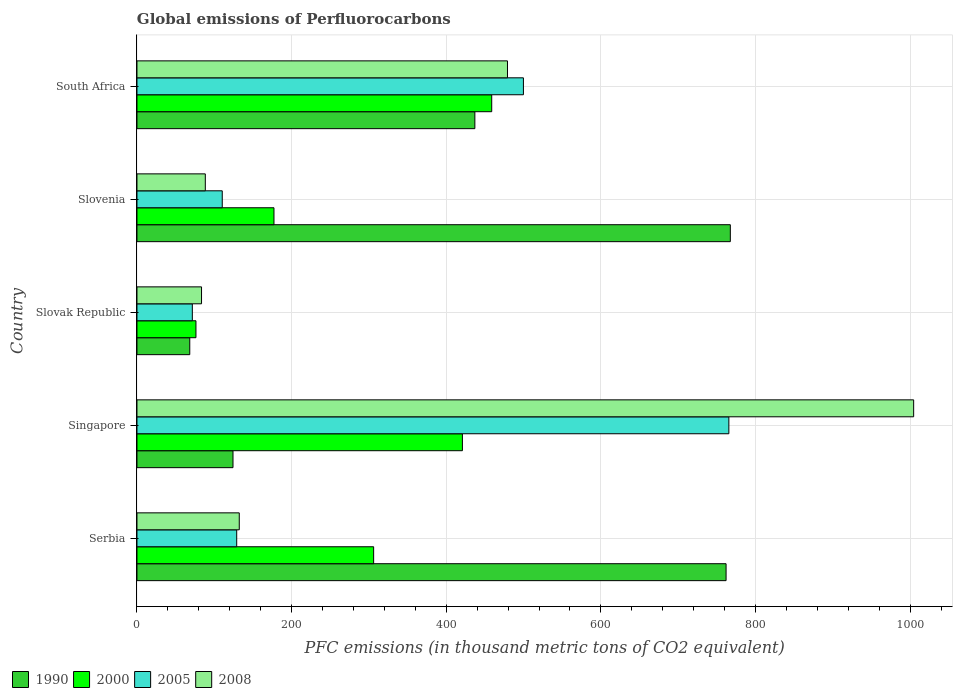How many groups of bars are there?
Your answer should be compact. 5. Are the number of bars on each tick of the Y-axis equal?
Keep it short and to the point. Yes. How many bars are there on the 5th tick from the bottom?
Your response must be concise. 4. What is the label of the 2nd group of bars from the top?
Ensure brevity in your answer.  Slovenia. In how many cases, is the number of bars for a given country not equal to the number of legend labels?
Your answer should be very brief. 0. What is the global emissions of Perfluorocarbons in 1990 in Slovenia?
Give a very brief answer. 767.4. Across all countries, what is the maximum global emissions of Perfluorocarbons in 2008?
Give a very brief answer. 1004.5. Across all countries, what is the minimum global emissions of Perfluorocarbons in 2005?
Your answer should be compact. 71.6. In which country was the global emissions of Perfluorocarbons in 2005 maximum?
Keep it short and to the point. Singapore. In which country was the global emissions of Perfluorocarbons in 1990 minimum?
Your answer should be compact. Slovak Republic. What is the total global emissions of Perfluorocarbons in 2005 in the graph?
Keep it short and to the point. 1576.2. What is the difference between the global emissions of Perfluorocarbons in 2008 in Slovak Republic and that in Slovenia?
Offer a terse response. -4.9. What is the difference between the global emissions of Perfluorocarbons in 2000 in Serbia and the global emissions of Perfluorocarbons in 2005 in South Africa?
Your answer should be very brief. -193.7. What is the average global emissions of Perfluorocarbons in 1990 per country?
Provide a short and direct response. 431.76. What is the difference between the global emissions of Perfluorocarbons in 2008 and global emissions of Perfluorocarbons in 1990 in Slovak Republic?
Offer a terse response. 15.2. In how many countries, is the global emissions of Perfluorocarbons in 1990 greater than 200 thousand metric tons?
Offer a terse response. 3. What is the ratio of the global emissions of Perfluorocarbons in 2000 in Singapore to that in South Africa?
Your response must be concise. 0.92. Is the global emissions of Perfluorocarbons in 2008 in Serbia less than that in Slovenia?
Make the answer very short. No. Is the difference between the global emissions of Perfluorocarbons in 2008 in Serbia and South Africa greater than the difference between the global emissions of Perfluorocarbons in 1990 in Serbia and South Africa?
Provide a succinct answer. No. What is the difference between the highest and the second highest global emissions of Perfluorocarbons in 2000?
Offer a very short reply. 37.9. What is the difference between the highest and the lowest global emissions of Perfluorocarbons in 2000?
Your answer should be very brief. 382.5. Is the sum of the global emissions of Perfluorocarbons in 2008 in Slovak Republic and South Africa greater than the maximum global emissions of Perfluorocarbons in 1990 across all countries?
Provide a succinct answer. No. Is it the case that in every country, the sum of the global emissions of Perfluorocarbons in 1990 and global emissions of Perfluorocarbons in 2000 is greater than the sum of global emissions of Perfluorocarbons in 2005 and global emissions of Perfluorocarbons in 2008?
Offer a terse response. No. What does the 3rd bar from the top in Serbia represents?
Make the answer very short. 2000. Does the graph contain any zero values?
Offer a very short reply. No. Does the graph contain grids?
Make the answer very short. Yes. How many legend labels are there?
Provide a short and direct response. 4. How are the legend labels stacked?
Provide a succinct answer. Horizontal. What is the title of the graph?
Give a very brief answer. Global emissions of Perfluorocarbons. What is the label or title of the X-axis?
Keep it short and to the point. PFC emissions (in thousand metric tons of CO2 equivalent). What is the PFC emissions (in thousand metric tons of CO2 equivalent) in 1990 in Serbia?
Your response must be concise. 761.9. What is the PFC emissions (in thousand metric tons of CO2 equivalent) of 2000 in Serbia?
Ensure brevity in your answer.  306.1. What is the PFC emissions (in thousand metric tons of CO2 equivalent) in 2005 in Serbia?
Your answer should be very brief. 129. What is the PFC emissions (in thousand metric tons of CO2 equivalent) of 2008 in Serbia?
Offer a very short reply. 132.3. What is the PFC emissions (in thousand metric tons of CO2 equivalent) in 1990 in Singapore?
Make the answer very short. 124.2. What is the PFC emissions (in thousand metric tons of CO2 equivalent) in 2000 in Singapore?
Your answer should be compact. 420.9. What is the PFC emissions (in thousand metric tons of CO2 equivalent) in 2005 in Singapore?
Your response must be concise. 765.5. What is the PFC emissions (in thousand metric tons of CO2 equivalent) of 2008 in Singapore?
Your answer should be very brief. 1004.5. What is the PFC emissions (in thousand metric tons of CO2 equivalent) of 1990 in Slovak Republic?
Provide a succinct answer. 68.3. What is the PFC emissions (in thousand metric tons of CO2 equivalent) in 2000 in Slovak Republic?
Make the answer very short. 76.3. What is the PFC emissions (in thousand metric tons of CO2 equivalent) of 2005 in Slovak Republic?
Make the answer very short. 71.6. What is the PFC emissions (in thousand metric tons of CO2 equivalent) of 2008 in Slovak Republic?
Offer a terse response. 83.5. What is the PFC emissions (in thousand metric tons of CO2 equivalent) of 1990 in Slovenia?
Keep it short and to the point. 767.4. What is the PFC emissions (in thousand metric tons of CO2 equivalent) of 2000 in Slovenia?
Your response must be concise. 177.2. What is the PFC emissions (in thousand metric tons of CO2 equivalent) in 2005 in Slovenia?
Keep it short and to the point. 110.3. What is the PFC emissions (in thousand metric tons of CO2 equivalent) in 2008 in Slovenia?
Your answer should be compact. 88.4. What is the PFC emissions (in thousand metric tons of CO2 equivalent) in 1990 in South Africa?
Keep it short and to the point. 437. What is the PFC emissions (in thousand metric tons of CO2 equivalent) of 2000 in South Africa?
Provide a short and direct response. 458.8. What is the PFC emissions (in thousand metric tons of CO2 equivalent) of 2005 in South Africa?
Offer a terse response. 499.8. What is the PFC emissions (in thousand metric tons of CO2 equivalent) of 2008 in South Africa?
Your response must be concise. 479.2. Across all countries, what is the maximum PFC emissions (in thousand metric tons of CO2 equivalent) of 1990?
Offer a terse response. 767.4. Across all countries, what is the maximum PFC emissions (in thousand metric tons of CO2 equivalent) of 2000?
Your answer should be compact. 458.8. Across all countries, what is the maximum PFC emissions (in thousand metric tons of CO2 equivalent) of 2005?
Your response must be concise. 765.5. Across all countries, what is the maximum PFC emissions (in thousand metric tons of CO2 equivalent) in 2008?
Ensure brevity in your answer.  1004.5. Across all countries, what is the minimum PFC emissions (in thousand metric tons of CO2 equivalent) of 1990?
Provide a succinct answer. 68.3. Across all countries, what is the minimum PFC emissions (in thousand metric tons of CO2 equivalent) in 2000?
Ensure brevity in your answer.  76.3. Across all countries, what is the minimum PFC emissions (in thousand metric tons of CO2 equivalent) of 2005?
Your response must be concise. 71.6. Across all countries, what is the minimum PFC emissions (in thousand metric tons of CO2 equivalent) in 2008?
Offer a terse response. 83.5. What is the total PFC emissions (in thousand metric tons of CO2 equivalent) of 1990 in the graph?
Make the answer very short. 2158.8. What is the total PFC emissions (in thousand metric tons of CO2 equivalent) of 2000 in the graph?
Your response must be concise. 1439.3. What is the total PFC emissions (in thousand metric tons of CO2 equivalent) of 2005 in the graph?
Your answer should be compact. 1576.2. What is the total PFC emissions (in thousand metric tons of CO2 equivalent) in 2008 in the graph?
Ensure brevity in your answer.  1787.9. What is the difference between the PFC emissions (in thousand metric tons of CO2 equivalent) in 1990 in Serbia and that in Singapore?
Ensure brevity in your answer.  637.7. What is the difference between the PFC emissions (in thousand metric tons of CO2 equivalent) of 2000 in Serbia and that in Singapore?
Keep it short and to the point. -114.8. What is the difference between the PFC emissions (in thousand metric tons of CO2 equivalent) in 2005 in Serbia and that in Singapore?
Give a very brief answer. -636.5. What is the difference between the PFC emissions (in thousand metric tons of CO2 equivalent) of 2008 in Serbia and that in Singapore?
Offer a terse response. -872.2. What is the difference between the PFC emissions (in thousand metric tons of CO2 equivalent) in 1990 in Serbia and that in Slovak Republic?
Offer a very short reply. 693.6. What is the difference between the PFC emissions (in thousand metric tons of CO2 equivalent) of 2000 in Serbia and that in Slovak Republic?
Your response must be concise. 229.8. What is the difference between the PFC emissions (in thousand metric tons of CO2 equivalent) of 2005 in Serbia and that in Slovak Republic?
Keep it short and to the point. 57.4. What is the difference between the PFC emissions (in thousand metric tons of CO2 equivalent) in 2008 in Serbia and that in Slovak Republic?
Your response must be concise. 48.8. What is the difference between the PFC emissions (in thousand metric tons of CO2 equivalent) in 2000 in Serbia and that in Slovenia?
Your response must be concise. 128.9. What is the difference between the PFC emissions (in thousand metric tons of CO2 equivalent) of 2005 in Serbia and that in Slovenia?
Ensure brevity in your answer.  18.7. What is the difference between the PFC emissions (in thousand metric tons of CO2 equivalent) of 2008 in Serbia and that in Slovenia?
Give a very brief answer. 43.9. What is the difference between the PFC emissions (in thousand metric tons of CO2 equivalent) in 1990 in Serbia and that in South Africa?
Your answer should be very brief. 324.9. What is the difference between the PFC emissions (in thousand metric tons of CO2 equivalent) of 2000 in Serbia and that in South Africa?
Give a very brief answer. -152.7. What is the difference between the PFC emissions (in thousand metric tons of CO2 equivalent) of 2005 in Serbia and that in South Africa?
Keep it short and to the point. -370.8. What is the difference between the PFC emissions (in thousand metric tons of CO2 equivalent) of 2008 in Serbia and that in South Africa?
Your answer should be very brief. -346.9. What is the difference between the PFC emissions (in thousand metric tons of CO2 equivalent) in 1990 in Singapore and that in Slovak Republic?
Keep it short and to the point. 55.9. What is the difference between the PFC emissions (in thousand metric tons of CO2 equivalent) in 2000 in Singapore and that in Slovak Republic?
Offer a terse response. 344.6. What is the difference between the PFC emissions (in thousand metric tons of CO2 equivalent) of 2005 in Singapore and that in Slovak Republic?
Provide a succinct answer. 693.9. What is the difference between the PFC emissions (in thousand metric tons of CO2 equivalent) of 2008 in Singapore and that in Slovak Republic?
Provide a succinct answer. 921. What is the difference between the PFC emissions (in thousand metric tons of CO2 equivalent) of 1990 in Singapore and that in Slovenia?
Offer a very short reply. -643.2. What is the difference between the PFC emissions (in thousand metric tons of CO2 equivalent) of 2000 in Singapore and that in Slovenia?
Your response must be concise. 243.7. What is the difference between the PFC emissions (in thousand metric tons of CO2 equivalent) in 2005 in Singapore and that in Slovenia?
Provide a short and direct response. 655.2. What is the difference between the PFC emissions (in thousand metric tons of CO2 equivalent) of 2008 in Singapore and that in Slovenia?
Offer a very short reply. 916.1. What is the difference between the PFC emissions (in thousand metric tons of CO2 equivalent) in 1990 in Singapore and that in South Africa?
Keep it short and to the point. -312.8. What is the difference between the PFC emissions (in thousand metric tons of CO2 equivalent) of 2000 in Singapore and that in South Africa?
Keep it short and to the point. -37.9. What is the difference between the PFC emissions (in thousand metric tons of CO2 equivalent) in 2005 in Singapore and that in South Africa?
Provide a succinct answer. 265.7. What is the difference between the PFC emissions (in thousand metric tons of CO2 equivalent) in 2008 in Singapore and that in South Africa?
Your response must be concise. 525.3. What is the difference between the PFC emissions (in thousand metric tons of CO2 equivalent) in 1990 in Slovak Republic and that in Slovenia?
Offer a terse response. -699.1. What is the difference between the PFC emissions (in thousand metric tons of CO2 equivalent) in 2000 in Slovak Republic and that in Slovenia?
Provide a short and direct response. -100.9. What is the difference between the PFC emissions (in thousand metric tons of CO2 equivalent) in 2005 in Slovak Republic and that in Slovenia?
Offer a very short reply. -38.7. What is the difference between the PFC emissions (in thousand metric tons of CO2 equivalent) in 1990 in Slovak Republic and that in South Africa?
Ensure brevity in your answer.  -368.7. What is the difference between the PFC emissions (in thousand metric tons of CO2 equivalent) in 2000 in Slovak Republic and that in South Africa?
Ensure brevity in your answer.  -382.5. What is the difference between the PFC emissions (in thousand metric tons of CO2 equivalent) in 2005 in Slovak Republic and that in South Africa?
Ensure brevity in your answer.  -428.2. What is the difference between the PFC emissions (in thousand metric tons of CO2 equivalent) in 2008 in Slovak Republic and that in South Africa?
Keep it short and to the point. -395.7. What is the difference between the PFC emissions (in thousand metric tons of CO2 equivalent) of 1990 in Slovenia and that in South Africa?
Your response must be concise. 330.4. What is the difference between the PFC emissions (in thousand metric tons of CO2 equivalent) in 2000 in Slovenia and that in South Africa?
Ensure brevity in your answer.  -281.6. What is the difference between the PFC emissions (in thousand metric tons of CO2 equivalent) in 2005 in Slovenia and that in South Africa?
Give a very brief answer. -389.5. What is the difference between the PFC emissions (in thousand metric tons of CO2 equivalent) of 2008 in Slovenia and that in South Africa?
Your response must be concise. -390.8. What is the difference between the PFC emissions (in thousand metric tons of CO2 equivalent) in 1990 in Serbia and the PFC emissions (in thousand metric tons of CO2 equivalent) in 2000 in Singapore?
Offer a very short reply. 341. What is the difference between the PFC emissions (in thousand metric tons of CO2 equivalent) of 1990 in Serbia and the PFC emissions (in thousand metric tons of CO2 equivalent) of 2008 in Singapore?
Ensure brevity in your answer.  -242.6. What is the difference between the PFC emissions (in thousand metric tons of CO2 equivalent) of 2000 in Serbia and the PFC emissions (in thousand metric tons of CO2 equivalent) of 2005 in Singapore?
Your answer should be compact. -459.4. What is the difference between the PFC emissions (in thousand metric tons of CO2 equivalent) of 2000 in Serbia and the PFC emissions (in thousand metric tons of CO2 equivalent) of 2008 in Singapore?
Your response must be concise. -698.4. What is the difference between the PFC emissions (in thousand metric tons of CO2 equivalent) of 2005 in Serbia and the PFC emissions (in thousand metric tons of CO2 equivalent) of 2008 in Singapore?
Give a very brief answer. -875.5. What is the difference between the PFC emissions (in thousand metric tons of CO2 equivalent) of 1990 in Serbia and the PFC emissions (in thousand metric tons of CO2 equivalent) of 2000 in Slovak Republic?
Your response must be concise. 685.6. What is the difference between the PFC emissions (in thousand metric tons of CO2 equivalent) in 1990 in Serbia and the PFC emissions (in thousand metric tons of CO2 equivalent) in 2005 in Slovak Republic?
Provide a succinct answer. 690.3. What is the difference between the PFC emissions (in thousand metric tons of CO2 equivalent) of 1990 in Serbia and the PFC emissions (in thousand metric tons of CO2 equivalent) of 2008 in Slovak Republic?
Ensure brevity in your answer.  678.4. What is the difference between the PFC emissions (in thousand metric tons of CO2 equivalent) of 2000 in Serbia and the PFC emissions (in thousand metric tons of CO2 equivalent) of 2005 in Slovak Republic?
Provide a short and direct response. 234.5. What is the difference between the PFC emissions (in thousand metric tons of CO2 equivalent) in 2000 in Serbia and the PFC emissions (in thousand metric tons of CO2 equivalent) in 2008 in Slovak Republic?
Ensure brevity in your answer.  222.6. What is the difference between the PFC emissions (in thousand metric tons of CO2 equivalent) in 2005 in Serbia and the PFC emissions (in thousand metric tons of CO2 equivalent) in 2008 in Slovak Republic?
Give a very brief answer. 45.5. What is the difference between the PFC emissions (in thousand metric tons of CO2 equivalent) of 1990 in Serbia and the PFC emissions (in thousand metric tons of CO2 equivalent) of 2000 in Slovenia?
Provide a short and direct response. 584.7. What is the difference between the PFC emissions (in thousand metric tons of CO2 equivalent) of 1990 in Serbia and the PFC emissions (in thousand metric tons of CO2 equivalent) of 2005 in Slovenia?
Your response must be concise. 651.6. What is the difference between the PFC emissions (in thousand metric tons of CO2 equivalent) in 1990 in Serbia and the PFC emissions (in thousand metric tons of CO2 equivalent) in 2008 in Slovenia?
Your response must be concise. 673.5. What is the difference between the PFC emissions (in thousand metric tons of CO2 equivalent) of 2000 in Serbia and the PFC emissions (in thousand metric tons of CO2 equivalent) of 2005 in Slovenia?
Offer a terse response. 195.8. What is the difference between the PFC emissions (in thousand metric tons of CO2 equivalent) in 2000 in Serbia and the PFC emissions (in thousand metric tons of CO2 equivalent) in 2008 in Slovenia?
Your answer should be compact. 217.7. What is the difference between the PFC emissions (in thousand metric tons of CO2 equivalent) in 2005 in Serbia and the PFC emissions (in thousand metric tons of CO2 equivalent) in 2008 in Slovenia?
Provide a succinct answer. 40.6. What is the difference between the PFC emissions (in thousand metric tons of CO2 equivalent) of 1990 in Serbia and the PFC emissions (in thousand metric tons of CO2 equivalent) of 2000 in South Africa?
Give a very brief answer. 303.1. What is the difference between the PFC emissions (in thousand metric tons of CO2 equivalent) in 1990 in Serbia and the PFC emissions (in thousand metric tons of CO2 equivalent) in 2005 in South Africa?
Your answer should be very brief. 262.1. What is the difference between the PFC emissions (in thousand metric tons of CO2 equivalent) of 1990 in Serbia and the PFC emissions (in thousand metric tons of CO2 equivalent) of 2008 in South Africa?
Your answer should be very brief. 282.7. What is the difference between the PFC emissions (in thousand metric tons of CO2 equivalent) of 2000 in Serbia and the PFC emissions (in thousand metric tons of CO2 equivalent) of 2005 in South Africa?
Provide a short and direct response. -193.7. What is the difference between the PFC emissions (in thousand metric tons of CO2 equivalent) of 2000 in Serbia and the PFC emissions (in thousand metric tons of CO2 equivalent) of 2008 in South Africa?
Your answer should be compact. -173.1. What is the difference between the PFC emissions (in thousand metric tons of CO2 equivalent) of 2005 in Serbia and the PFC emissions (in thousand metric tons of CO2 equivalent) of 2008 in South Africa?
Provide a succinct answer. -350.2. What is the difference between the PFC emissions (in thousand metric tons of CO2 equivalent) of 1990 in Singapore and the PFC emissions (in thousand metric tons of CO2 equivalent) of 2000 in Slovak Republic?
Give a very brief answer. 47.9. What is the difference between the PFC emissions (in thousand metric tons of CO2 equivalent) of 1990 in Singapore and the PFC emissions (in thousand metric tons of CO2 equivalent) of 2005 in Slovak Republic?
Your answer should be compact. 52.6. What is the difference between the PFC emissions (in thousand metric tons of CO2 equivalent) in 1990 in Singapore and the PFC emissions (in thousand metric tons of CO2 equivalent) in 2008 in Slovak Republic?
Your answer should be very brief. 40.7. What is the difference between the PFC emissions (in thousand metric tons of CO2 equivalent) of 2000 in Singapore and the PFC emissions (in thousand metric tons of CO2 equivalent) of 2005 in Slovak Republic?
Your answer should be compact. 349.3. What is the difference between the PFC emissions (in thousand metric tons of CO2 equivalent) of 2000 in Singapore and the PFC emissions (in thousand metric tons of CO2 equivalent) of 2008 in Slovak Republic?
Provide a succinct answer. 337.4. What is the difference between the PFC emissions (in thousand metric tons of CO2 equivalent) of 2005 in Singapore and the PFC emissions (in thousand metric tons of CO2 equivalent) of 2008 in Slovak Republic?
Provide a short and direct response. 682. What is the difference between the PFC emissions (in thousand metric tons of CO2 equivalent) of 1990 in Singapore and the PFC emissions (in thousand metric tons of CO2 equivalent) of 2000 in Slovenia?
Your response must be concise. -53. What is the difference between the PFC emissions (in thousand metric tons of CO2 equivalent) of 1990 in Singapore and the PFC emissions (in thousand metric tons of CO2 equivalent) of 2005 in Slovenia?
Ensure brevity in your answer.  13.9. What is the difference between the PFC emissions (in thousand metric tons of CO2 equivalent) of 1990 in Singapore and the PFC emissions (in thousand metric tons of CO2 equivalent) of 2008 in Slovenia?
Keep it short and to the point. 35.8. What is the difference between the PFC emissions (in thousand metric tons of CO2 equivalent) of 2000 in Singapore and the PFC emissions (in thousand metric tons of CO2 equivalent) of 2005 in Slovenia?
Ensure brevity in your answer.  310.6. What is the difference between the PFC emissions (in thousand metric tons of CO2 equivalent) in 2000 in Singapore and the PFC emissions (in thousand metric tons of CO2 equivalent) in 2008 in Slovenia?
Your answer should be compact. 332.5. What is the difference between the PFC emissions (in thousand metric tons of CO2 equivalent) of 2005 in Singapore and the PFC emissions (in thousand metric tons of CO2 equivalent) of 2008 in Slovenia?
Make the answer very short. 677.1. What is the difference between the PFC emissions (in thousand metric tons of CO2 equivalent) of 1990 in Singapore and the PFC emissions (in thousand metric tons of CO2 equivalent) of 2000 in South Africa?
Your answer should be compact. -334.6. What is the difference between the PFC emissions (in thousand metric tons of CO2 equivalent) of 1990 in Singapore and the PFC emissions (in thousand metric tons of CO2 equivalent) of 2005 in South Africa?
Provide a succinct answer. -375.6. What is the difference between the PFC emissions (in thousand metric tons of CO2 equivalent) of 1990 in Singapore and the PFC emissions (in thousand metric tons of CO2 equivalent) of 2008 in South Africa?
Keep it short and to the point. -355. What is the difference between the PFC emissions (in thousand metric tons of CO2 equivalent) of 2000 in Singapore and the PFC emissions (in thousand metric tons of CO2 equivalent) of 2005 in South Africa?
Your answer should be compact. -78.9. What is the difference between the PFC emissions (in thousand metric tons of CO2 equivalent) in 2000 in Singapore and the PFC emissions (in thousand metric tons of CO2 equivalent) in 2008 in South Africa?
Provide a short and direct response. -58.3. What is the difference between the PFC emissions (in thousand metric tons of CO2 equivalent) in 2005 in Singapore and the PFC emissions (in thousand metric tons of CO2 equivalent) in 2008 in South Africa?
Provide a succinct answer. 286.3. What is the difference between the PFC emissions (in thousand metric tons of CO2 equivalent) in 1990 in Slovak Republic and the PFC emissions (in thousand metric tons of CO2 equivalent) in 2000 in Slovenia?
Offer a very short reply. -108.9. What is the difference between the PFC emissions (in thousand metric tons of CO2 equivalent) in 1990 in Slovak Republic and the PFC emissions (in thousand metric tons of CO2 equivalent) in 2005 in Slovenia?
Make the answer very short. -42. What is the difference between the PFC emissions (in thousand metric tons of CO2 equivalent) in 1990 in Slovak Republic and the PFC emissions (in thousand metric tons of CO2 equivalent) in 2008 in Slovenia?
Provide a succinct answer. -20.1. What is the difference between the PFC emissions (in thousand metric tons of CO2 equivalent) in 2000 in Slovak Republic and the PFC emissions (in thousand metric tons of CO2 equivalent) in 2005 in Slovenia?
Your answer should be compact. -34. What is the difference between the PFC emissions (in thousand metric tons of CO2 equivalent) in 2000 in Slovak Republic and the PFC emissions (in thousand metric tons of CO2 equivalent) in 2008 in Slovenia?
Offer a very short reply. -12.1. What is the difference between the PFC emissions (in thousand metric tons of CO2 equivalent) in 2005 in Slovak Republic and the PFC emissions (in thousand metric tons of CO2 equivalent) in 2008 in Slovenia?
Make the answer very short. -16.8. What is the difference between the PFC emissions (in thousand metric tons of CO2 equivalent) in 1990 in Slovak Republic and the PFC emissions (in thousand metric tons of CO2 equivalent) in 2000 in South Africa?
Keep it short and to the point. -390.5. What is the difference between the PFC emissions (in thousand metric tons of CO2 equivalent) in 1990 in Slovak Republic and the PFC emissions (in thousand metric tons of CO2 equivalent) in 2005 in South Africa?
Provide a short and direct response. -431.5. What is the difference between the PFC emissions (in thousand metric tons of CO2 equivalent) in 1990 in Slovak Republic and the PFC emissions (in thousand metric tons of CO2 equivalent) in 2008 in South Africa?
Offer a terse response. -410.9. What is the difference between the PFC emissions (in thousand metric tons of CO2 equivalent) in 2000 in Slovak Republic and the PFC emissions (in thousand metric tons of CO2 equivalent) in 2005 in South Africa?
Keep it short and to the point. -423.5. What is the difference between the PFC emissions (in thousand metric tons of CO2 equivalent) of 2000 in Slovak Republic and the PFC emissions (in thousand metric tons of CO2 equivalent) of 2008 in South Africa?
Keep it short and to the point. -402.9. What is the difference between the PFC emissions (in thousand metric tons of CO2 equivalent) in 2005 in Slovak Republic and the PFC emissions (in thousand metric tons of CO2 equivalent) in 2008 in South Africa?
Offer a terse response. -407.6. What is the difference between the PFC emissions (in thousand metric tons of CO2 equivalent) in 1990 in Slovenia and the PFC emissions (in thousand metric tons of CO2 equivalent) in 2000 in South Africa?
Make the answer very short. 308.6. What is the difference between the PFC emissions (in thousand metric tons of CO2 equivalent) in 1990 in Slovenia and the PFC emissions (in thousand metric tons of CO2 equivalent) in 2005 in South Africa?
Provide a short and direct response. 267.6. What is the difference between the PFC emissions (in thousand metric tons of CO2 equivalent) in 1990 in Slovenia and the PFC emissions (in thousand metric tons of CO2 equivalent) in 2008 in South Africa?
Provide a succinct answer. 288.2. What is the difference between the PFC emissions (in thousand metric tons of CO2 equivalent) in 2000 in Slovenia and the PFC emissions (in thousand metric tons of CO2 equivalent) in 2005 in South Africa?
Ensure brevity in your answer.  -322.6. What is the difference between the PFC emissions (in thousand metric tons of CO2 equivalent) of 2000 in Slovenia and the PFC emissions (in thousand metric tons of CO2 equivalent) of 2008 in South Africa?
Your response must be concise. -302. What is the difference between the PFC emissions (in thousand metric tons of CO2 equivalent) in 2005 in Slovenia and the PFC emissions (in thousand metric tons of CO2 equivalent) in 2008 in South Africa?
Ensure brevity in your answer.  -368.9. What is the average PFC emissions (in thousand metric tons of CO2 equivalent) in 1990 per country?
Your response must be concise. 431.76. What is the average PFC emissions (in thousand metric tons of CO2 equivalent) of 2000 per country?
Your answer should be very brief. 287.86. What is the average PFC emissions (in thousand metric tons of CO2 equivalent) in 2005 per country?
Your answer should be very brief. 315.24. What is the average PFC emissions (in thousand metric tons of CO2 equivalent) of 2008 per country?
Your response must be concise. 357.58. What is the difference between the PFC emissions (in thousand metric tons of CO2 equivalent) of 1990 and PFC emissions (in thousand metric tons of CO2 equivalent) of 2000 in Serbia?
Provide a succinct answer. 455.8. What is the difference between the PFC emissions (in thousand metric tons of CO2 equivalent) of 1990 and PFC emissions (in thousand metric tons of CO2 equivalent) of 2005 in Serbia?
Give a very brief answer. 632.9. What is the difference between the PFC emissions (in thousand metric tons of CO2 equivalent) in 1990 and PFC emissions (in thousand metric tons of CO2 equivalent) in 2008 in Serbia?
Your answer should be very brief. 629.6. What is the difference between the PFC emissions (in thousand metric tons of CO2 equivalent) in 2000 and PFC emissions (in thousand metric tons of CO2 equivalent) in 2005 in Serbia?
Provide a short and direct response. 177.1. What is the difference between the PFC emissions (in thousand metric tons of CO2 equivalent) of 2000 and PFC emissions (in thousand metric tons of CO2 equivalent) of 2008 in Serbia?
Provide a succinct answer. 173.8. What is the difference between the PFC emissions (in thousand metric tons of CO2 equivalent) of 2005 and PFC emissions (in thousand metric tons of CO2 equivalent) of 2008 in Serbia?
Offer a terse response. -3.3. What is the difference between the PFC emissions (in thousand metric tons of CO2 equivalent) in 1990 and PFC emissions (in thousand metric tons of CO2 equivalent) in 2000 in Singapore?
Keep it short and to the point. -296.7. What is the difference between the PFC emissions (in thousand metric tons of CO2 equivalent) of 1990 and PFC emissions (in thousand metric tons of CO2 equivalent) of 2005 in Singapore?
Your answer should be compact. -641.3. What is the difference between the PFC emissions (in thousand metric tons of CO2 equivalent) of 1990 and PFC emissions (in thousand metric tons of CO2 equivalent) of 2008 in Singapore?
Offer a terse response. -880.3. What is the difference between the PFC emissions (in thousand metric tons of CO2 equivalent) of 2000 and PFC emissions (in thousand metric tons of CO2 equivalent) of 2005 in Singapore?
Offer a very short reply. -344.6. What is the difference between the PFC emissions (in thousand metric tons of CO2 equivalent) in 2000 and PFC emissions (in thousand metric tons of CO2 equivalent) in 2008 in Singapore?
Provide a short and direct response. -583.6. What is the difference between the PFC emissions (in thousand metric tons of CO2 equivalent) in 2005 and PFC emissions (in thousand metric tons of CO2 equivalent) in 2008 in Singapore?
Give a very brief answer. -239. What is the difference between the PFC emissions (in thousand metric tons of CO2 equivalent) in 1990 and PFC emissions (in thousand metric tons of CO2 equivalent) in 2000 in Slovak Republic?
Provide a short and direct response. -8. What is the difference between the PFC emissions (in thousand metric tons of CO2 equivalent) in 1990 and PFC emissions (in thousand metric tons of CO2 equivalent) in 2008 in Slovak Republic?
Make the answer very short. -15.2. What is the difference between the PFC emissions (in thousand metric tons of CO2 equivalent) of 2005 and PFC emissions (in thousand metric tons of CO2 equivalent) of 2008 in Slovak Republic?
Offer a very short reply. -11.9. What is the difference between the PFC emissions (in thousand metric tons of CO2 equivalent) in 1990 and PFC emissions (in thousand metric tons of CO2 equivalent) in 2000 in Slovenia?
Your answer should be compact. 590.2. What is the difference between the PFC emissions (in thousand metric tons of CO2 equivalent) of 1990 and PFC emissions (in thousand metric tons of CO2 equivalent) of 2005 in Slovenia?
Offer a terse response. 657.1. What is the difference between the PFC emissions (in thousand metric tons of CO2 equivalent) in 1990 and PFC emissions (in thousand metric tons of CO2 equivalent) in 2008 in Slovenia?
Give a very brief answer. 679. What is the difference between the PFC emissions (in thousand metric tons of CO2 equivalent) of 2000 and PFC emissions (in thousand metric tons of CO2 equivalent) of 2005 in Slovenia?
Make the answer very short. 66.9. What is the difference between the PFC emissions (in thousand metric tons of CO2 equivalent) in 2000 and PFC emissions (in thousand metric tons of CO2 equivalent) in 2008 in Slovenia?
Offer a very short reply. 88.8. What is the difference between the PFC emissions (in thousand metric tons of CO2 equivalent) in 2005 and PFC emissions (in thousand metric tons of CO2 equivalent) in 2008 in Slovenia?
Offer a terse response. 21.9. What is the difference between the PFC emissions (in thousand metric tons of CO2 equivalent) of 1990 and PFC emissions (in thousand metric tons of CO2 equivalent) of 2000 in South Africa?
Provide a short and direct response. -21.8. What is the difference between the PFC emissions (in thousand metric tons of CO2 equivalent) of 1990 and PFC emissions (in thousand metric tons of CO2 equivalent) of 2005 in South Africa?
Your answer should be very brief. -62.8. What is the difference between the PFC emissions (in thousand metric tons of CO2 equivalent) of 1990 and PFC emissions (in thousand metric tons of CO2 equivalent) of 2008 in South Africa?
Offer a very short reply. -42.2. What is the difference between the PFC emissions (in thousand metric tons of CO2 equivalent) in 2000 and PFC emissions (in thousand metric tons of CO2 equivalent) in 2005 in South Africa?
Keep it short and to the point. -41. What is the difference between the PFC emissions (in thousand metric tons of CO2 equivalent) of 2000 and PFC emissions (in thousand metric tons of CO2 equivalent) of 2008 in South Africa?
Offer a very short reply. -20.4. What is the difference between the PFC emissions (in thousand metric tons of CO2 equivalent) in 2005 and PFC emissions (in thousand metric tons of CO2 equivalent) in 2008 in South Africa?
Provide a short and direct response. 20.6. What is the ratio of the PFC emissions (in thousand metric tons of CO2 equivalent) of 1990 in Serbia to that in Singapore?
Give a very brief answer. 6.13. What is the ratio of the PFC emissions (in thousand metric tons of CO2 equivalent) in 2000 in Serbia to that in Singapore?
Provide a succinct answer. 0.73. What is the ratio of the PFC emissions (in thousand metric tons of CO2 equivalent) of 2005 in Serbia to that in Singapore?
Provide a short and direct response. 0.17. What is the ratio of the PFC emissions (in thousand metric tons of CO2 equivalent) of 2008 in Serbia to that in Singapore?
Ensure brevity in your answer.  0.13. What is the ratio of the PFC emissions (in thousand metric tons of CO2 equivalent) in 1990 in Serbia to that in Slovak Republic?
Provide a short and direct response. 11.16. What is the ratio of the PFC emissions (in thousand metric tons of CO2 equivalent) of 2000 in Serbia to that in Slovak Republic?
Give a very brief answer. 4.01. What is the ratio of the PFC emissions (in thousand metric tons of CO2 equivalent) in 2005 in Serbia to that in Slovak Republic?
Your answer should be very brief. 1.8. What is the ratio of the PFC emissions (in thousand metric tons of CO2 equivalent) of 2008 in Serbia to that in Slovak Republic?
Provide a succinct answer. 1.58. What is the ratio of the PFC emissions (in thousand metric tons of CO2 equivalent) in 1990 in Serbia to that in Slovenia?
Your answer should be compact. 0.99. What is the ratio of the PFC emissions (in thousand metric tons of CO2 equivalent) of 2000 in Serbia to that in Slovenia?
Ensure brevity in your answer.  1.73. What is the ratio of the PFC emissions (in thousand metric tons of CO2 equivalent) in 2005 in Serbia to that in Slovenia?
Offer a very short reply. 1.17. What is the ratio of the PFC emissions (in thousand metric tons of CO2 equivalent) in 2008 in Serbia to that in Slovenia?
Offer a very short reply. 1.5. What is the ratio of the PFC emissions (in thousand metric tons of CO2 equivalent) of 1990 in Serbia to that in South Africa?
Offer a very short reply. 1.74. What is the ratio of the PFC emissions (in thousand metric tons of CO2 equivalent) in 2000 in Serbia to that in South Africa?
Provide a succinct answer. 0.67. What is the ratio of the PFC emissions (in thousand metric tons of CO2 equivalent) of 2005 in Serbia to that in South Africa?
Your response must be concise. 0.26. What is the ratio of the PFC emissions (in thousand metric tons of CO2 equivalent) in 2008 in Serbia to that in South Africa?
Make the answer very short. 0.28. What is the ratio of the PFC emissions (in thousand metric tons of CO2 equivalent) in 1990 in Singapore to that in Slovak Republic?
Your answer should be very brief. 1.82. What is the ratio of the PFC emissions (in thousand metric tons of CO2 equivalent) of 2000 in Singapore to that in Slovak Republic?
Ensure brevity in your answer.  5.52. What is the ratio of the PFC emissions (in thousand metric tons of CO2 equivalent) in 2005 in Singapore to that in Slovak Republic?
Your answer should be compact. 10.69. What is the ratio of the PFC emissions (in thousand metric tons of CO2 equivalent) of 2008 in Singapore to that in Slovak Republic?
Offer a very short reply. 12.03. What is the ratio of the PFC emissions (in thousand metric tons of CO2 equivalent) of 1990 in Singapore to that in Slovenia?
Give a very brief answer. 0.16. What is the ratio of the PFC emissions (in thousand metric tons of CO2 equivalent) in 2000 in Singapore to that in Slovenia?
Make the answer very short. 2.38. What is the ratio of the PFC emissions (in thousand metric tons of CO2 equivalent) in 2005 in Singapore to that in Slovenia?
Ensure brevity in your answer.  6.94. What is the ratio of the PFC emissions (in thousand metric tons of CO2 equivalent) of 2008 in Singapore to that in Slovenia?
Make the answer very short. 11.36. What is the ratio of the PFC emissions (in thousand metric tons of CO2 equivalent) in 1990 in Singapore to that in South Africa?
Keep it short and to the point. 0.28. What is the ratio of the PFC emissions (in thousand metric tons of CO2 equivalent) in 2000 in Singapore to that in South Africa?
Provide a short and direct response. 0.92. What is the ratio of the PFC emissions (in thousand metric tons of CO2 equivalent) of 2005 in Singapore to that in South Africa?
Keep it short and to the point. 1.53. What is the ratio of the PFC emissions (in thousand metric tons of CO2 equivalent) of 2008 in Singapore to that in South Africa?
Give a very brief answer. 2.1. What is the ratio of the PFC emissions (in thousand metric tons of CO2 equivalent) of 1990 in Slovak Republic to that in Slovenia?
Keep it short and to the point. 0.09. What is the ratio of the PFC emissions (in thousand metric tons of CO2 equivalent) in 2000 in Slovak Republic to that in Slovenia?
Offer a very short reply. 0.43. What is the ratio of the PFC emissions (in thousand metric tons of CO2 equivalent) of 2005 in Slovak Republic to that in Slovenia?
Keep it short and to the point. 0.65. What is the ratio of the PFC emissions (in thousand metric tons of CO2 equivalent) of 2008 in Slovak Republic to that in Slovenia?
Your answer should be compact. 0.94. What is the ratio of the PFC emissions (in thousand metric tons of CO2 equivalent) of 1990 in Slovak Republic to that in South Africa?
Your response must be concise. 0.16. What is the ratio of the PFC emissions (in thousand metric tons of CO2 equivalent) of 2000 in Slovak Republic to that in South Africa?
Ensure brevity in your answer.  0.17. What is the ratio of the PFC emissions (in thousand metric tons of CO2 equivalent) in 2005 in Slovak Republic to that in South Africa?
Give a very brief answer. 0.14. What is the ratio of the PFC emissions (in thousand metric tons of CO2 equivalent) of 2008 in Slovak Republic to that in South Africa?
Your response must be concise. 0.17. What is the ratio of the PFC emissions (in thousand metric tons of CO2 equivalent) in 1990 in Slovenia to that in South Africa?
Provide a succinct answer. 1.76. What is the ratio of the PFC emissions (in thousand metric tons of CO2 equivalent) of 2000 in Slovenia to that in South Africa?
Provide a succinct answer. 0.39. What is the ratio of the PFC emissions (in thousand metric tons of CO2 equivalent) of 2005 in Slovenia to that in South Africa?
Make the answer very short. 0.22. What is the ratio of the PFC emissions (in thousand metric tons of CO2 equivalent) in 2008 in Slovenia to that in South Africa?
Your answer should be compact. 0.18. What is the difference between the highest and the second highest PFC emissions (in thousand metric tons of CO2 equivalent) in 2000?
Ensure brevity in your answer.  37.9. What is the difference between the highest and the second highest PFC emissions (in thousand metric tons of CO2 equivalent) in 2005?
Your answer should be compact. 265.7. What is the difference between the highest and the second highest PFC emissions (in thousand metric tons of CO2 equivalent) in 2008?
Offer a very short reply. 525.3. What is the difference between the highest and the lowest PFC emissions (in thousand metric tons of CO2 equivalent) of 1990?
Make the answer very short. 699.1. What is the difference between the highest and the lowest PFC emissions (in thousand metric tons of CO2 equivalent) of 2000?
Offer a very short reply. 382.5. What is the difference between the highest and the lowest PFC emissions (in thousand metric tons of CO2 equivalent) in 2005?
Provide a succinct answer. 693.9. What is the difference between the highest and the lowest PFC emissions (in thousand metric tons of CO2 equivalent) in 2008?
Offer a very short reply. 921. 